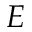<formula> <loc_0><loc_0><loc_500><loc_500>E</formula> 